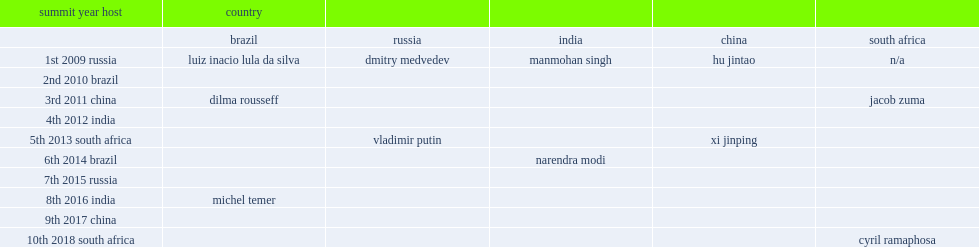Who has attended the brics (brazil, russia, india, china and south africa) summit conferences since 2013? Vladimir putin. 